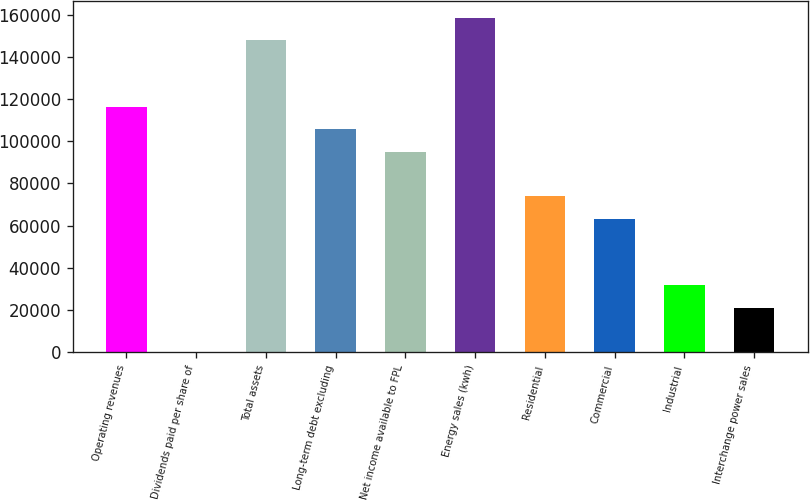<chart> <loc_0><loc_0><loc_500><loc_500><bar_chart><fcel>Operating revenues<fcel>Dividends paid per share of<fcel>Total assets<fcel>Long-term debt excluding<fcel>Net income available to FPL<fcel>Energy sales (kwh)<fcel>Residential<fcel>Commercial<fcel>Industrial<fcel>Interchange power sales<nl><fcel>116213<fcel>1.42<fcel>147907<fcel>105648<fcel>95083.4<fcel>158471<fcel>73954<fcel>63389.4<fcel>31695.4<fcel>21130.7<nl></chart> 